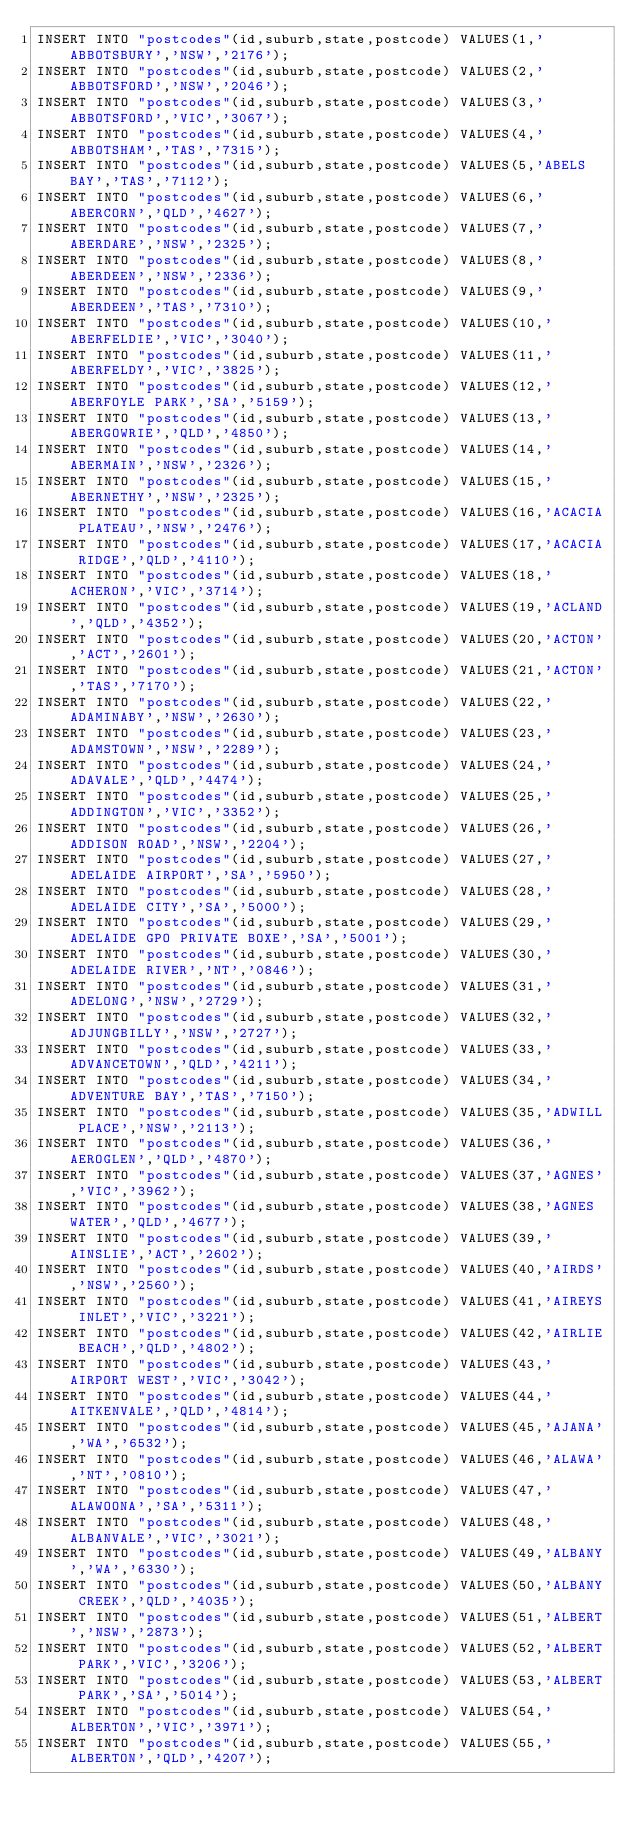<code> <loc_0><loc_0><loc_500><loc_500><_SQL_>INSERT INTO "postcodes"(id,suburb,state,postcode) VALUES(1,'ABBOTSBURY','NSW','2176');
INSERT INTO "postcodes"(id,suburb,state,postcode) VALUES(2,'ABBOTSFORD','NSW','2046');
INSERT INTO "postcodes"(id,suburb,state,postcode) VALUES(3,'ABBOTSFORD','VIC','3067');
INSERT INTO "postcodes"(id,suburb,state,postcode) VALUES(4,'ABBOTSHAM','TAS','7315');
INSERT INTO "postcodes"(id,suburb,state,postcode) VALUES(5,'ABELS BAY','TAS','7112');
INSERT INTO "postcodes"(id,suburb,state,postcode) VALUES(6,'ABERCORN','QLD','4627');
INSERT INTO "postcodes"(id,suburb,state,postcode) VALUES(7,'ABERDARE','NSW','2325');
INSERT INTO "postcodes"(id,suburb,state,postcode) VALUES(8,'ABERDEEN','NSW','2336');
INSERT INTO "postcodes"(id,suburb,state,postcode) VALUES(9,'ABERDEEN','TAS','7310');
INSERT INTO "postcodes"(id,suburb,state,postcode) VALUES(10,'ABERFELDIE','VIC','3040');
INSERT INTO "postcodes"(id,suburb,state,postcode) VALUES(11,'ABERFELDY','VIC','3825');
INSERT INTO "postcodes"(id,suburb,state,postcode) VALUES(12,'ABERFOYLE PARK','SA','5159');
INSERT INTO "postcodes"(id,suburb,state,postcode) VALUES(13,'ABERGOWRIE','QLD','4850');
INSERT INTO "postcodes"(id,suburb,state,postcode) VALUES(14,'ABERMAIN','NSW','2326');
INSERT INTO "postcodes"(id,suburb,state,postcode) VALUES(15,'ABERNETHY','NSW','2325');
INSERT INTO "postcodes"(id,suburb,state,postcode) VALUES(16,'ACACIA PLATEAU','NSW','2476');
INSERT INTO "postcodes"(id,suburb,state,postcode) VALUES(17,'ACACIA RIDGE','QLD','4110');
INSERT INTO "postcodes"(id,suburb,state,postcode) VALUES(18,'ACHERON','VIC','3714');
INSERT INTO "postcodes"(id,suburb,state,postcode) VALUES(19,'ACLAND','QLD','4352');
INSERT INTO "postcodes"(id,suburb,state,postcode) VALUES(20,'ACTON','ACT','2601');
INSERT INTO "postcodes"(id,suburb,state,postcode) VALUES(21,'ACTON','TAS','7170');
INSERT INTO "postcodes"(id,suburb,state,postcode) VALUES(22,'ADAMINABY','NSW','2630');
INSERT INTO "postcodes"(id,suburb,state,postcode) VALUES(23,'ADAMSTOWN','NSW','2289');
INSERT INTO "postcodes"(id,suburb,state,postcode) VALUES(24,'ADAVALE','QLD','4474');
INSERT INTO "postcodes"(id,suburb,state,postcode) VALUES(25,'ADDINGTON','VIC','3352');
INSERT INTO "postcodes"(id,suburb,state,postcode) VALUES(26,'ADDISON ROAD','NSW','2204');
INSERT INTO "postcodes"(id,suburb,state,postcode) VALUES(27,'ADELAIDE AIRPORT','SA','5950');
INSERT INTO "postcodes"(id,suburb,state,postcode) VALUES(28,'ADELAIDE CITY','SA','5000');
INSERT INTO "postcodes"(id,suburb,state,postcode) VALUES(29,'ADELAIDE GPO PRIVATE BOXE','SA','5001');
INSERT INTO "postcodes"(id,suburb,state,postcode) VALUES(30,'ADELAIDE RIVER','NT','0846');
INSERT INTO "postcodes"(id,suburb,state,postcode) VALUES(31,'ADELONG','NSW','2729');
INSERT INTO "postcodes"(id,suburb,state,postcode) VALUES(32,'ADJUNGBILLY','NSW','2727');
INSERT INTO "postcodes"(id,suburb,state,postcode) VALUES(33,'ADVANCETOWN','QLD','4211');
INSERT INTO "postcodes"(id,suburb,state,postcode) VALUES(34,'ADVENTURE BAY','TAS','7150');
INSERT INTO "postcodes"(id,suburb,state,postcode) VALUES(35,'ADWILL PLACE','NSW','2113');
INSERT INTO "postcodes"(id,suburb,state,postcode) VALUES(36,'AEROGLEN','QLD','4870');
INSERT INTO "postcodes"(id,suburb,state,postcode) VALUES(37,'AGNES','VIC','3962');
INSERT INTO "postcodes"(id,suburb,state,postcode) VALUES(38,'AGNES WATER','QLD','4677');
INSERT INTO "postcodes"(id,suburb,state,postcode) VALUES(39,'AINSLIE','ACT','2602');
INSERT INTO "postcodes"(id,suburb,state,postcode) VALUES(40,'AIRDS','NSW','2560');
INSERT INTO "postcodes"(id,suburb,state,postcode) VALUES(41,'AIREYS INLET','VIC','3221');
INSERT INTO "postcodes"(id,suburb,state,postcode) VALUES(42,'AIRLIE BEACH','QLD','4802');
INSERT INTO "postcodes"(id,suburb,state,postcode) VALUES(43,'AIRPORT WEST','VIC','3042');
INSERT INTO "postcodes"(id,suburb,state,postcode) VALUES(44,'AITKENVALE','QLD','4814');
INSERT INTO "postcodes"(id,suburb,state,postcode) VALUES(45,'AJANA','WA','6532');
INSERT INTO "postcodes"(id,suburb,state,postcode) VALUES(46,'ALAWA','NT','0810');
INSERT INTO "postcodes"(id,suburb,state,postcode) VALUES(47,'ALAWOONA','SA','5311');
INSERT INTO "postcodes"(id,suburb,state,postcode) VALUES(48,'ALBANVALE','VIC','3021');
INSERT INTO "postcodes"(id,suburb,state,postcode) VALUES(49,'ALBANY','WA','6330');
INSERT INTO "postcodes"(id,suburb,state,postcode) VALUES(50,'ALBANY CREEK','QLD','4035');
INSERT INTO "postcodes"(id,suburb,state,postcode) VALUES(51,'ALBERT','NSW','2873');
INSERT INTO "postcodes"(id,suburb,state,postcode) VALUES(52,'ALBERT PARK','VIC','3206');
INSERT INTO "postcodes"(id,suburb,state,postcode) VALUES(53,'ALBERT PARK','SA','5014');
INSERT INTO "postcodes"(id,suburb,state,postcode) VALUES(54,'ALBERTON','VIC','3971');
INSERT INTO "postcodes"(id,suburb,state,postcode) VALUES(55,'ALBERTON','QLD','4207');</code> 